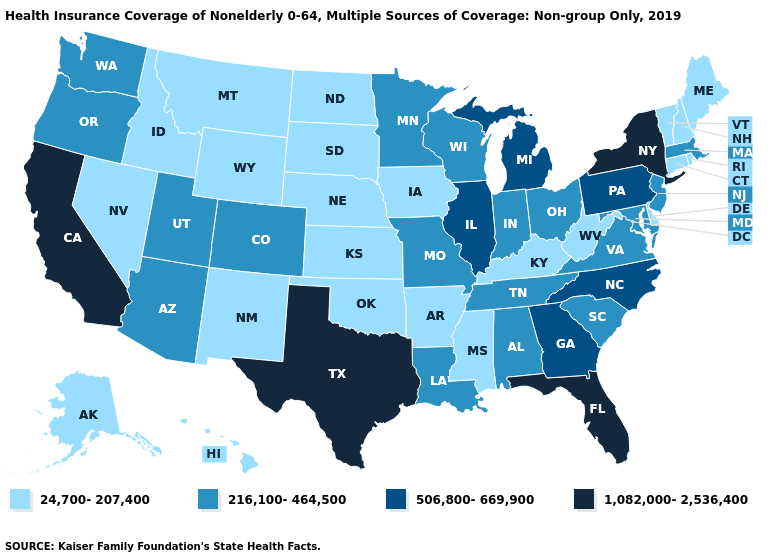Among the states that border Maryland , which have the lowest value?
Be succinct. Delaware, West Virginia. Does the first symbol in the legend represent the smallest category?
Concise answer only. Yes. Among the states that border Georgia , which have the highest value?
Write a very short answer. Florida. Which states hav the highest value in the South?
Answer briefly. Florida, Texas. Which states have the lowest value in the USA?
Be succinct. Alaska, Arkansas, Connecticut, Delaware, Hawaii, Idaho, Iowa, Kansas, Kentucky, Maine, Mississippi, Montana, Nebraska, Nevada, New Hampshire, New Mexico, North Dakota, Oklahoma, Rhode Island, South Dakota, Vermont, West Virginia, Wyoming. What is the lowest value in states that border Kansas?
Keep it brief. 24,700-207,400. Name the states that have a value in the range 1,082,000-2,536,400?
Be succinct. California, Florida, New York, Texas. Does Missouri have the lowest value in the MidWest?
Write a very short answer. No. Name the states that have a value in the range 1,082,000-2,536,400?
Quick response, please. California, Florida, New York, Texas. Name the states that have a value in the range 216,100-464,500?
Write a very short answer. Alabama, Arizona, Colorado, Indiana, Louisiana, Maryland, Massachusetts, Minnesota, Missouri, New Jersey, Ohio, Oregon, South Carolina, Tennessee, Utah, Virginia, Washington, Wisconsin. Name the states that have a value in the range 1,082,000-2,536,400?
Answer briefly. California, Florida, New York, Texas. Which states have the lowest value in the MidWest?
Short answer required. Iowa, Kansas, Nebraska, North Dakota, South Dakota. Name the states that have a value in the range 24,700-207,400?
Concise answer only. Alaska, Arkansas, Connecticut, Delaware, Hawaii, Idaho, Iowa, Kansas, Kentucky, Maine, Mississippi, Montana, Nebraska, Nevada, New Hampshire, New Mexico, North Dakota, Oklahoma, Rhode Island, South Dakota, Vermont, West Virginia, Wyoming. Among the states that border Virginia , which have the highest value?
Write a very short answer. North Carolina. What is the lowest value in the Northeast?
Short answer required. 24,700-207,400. 